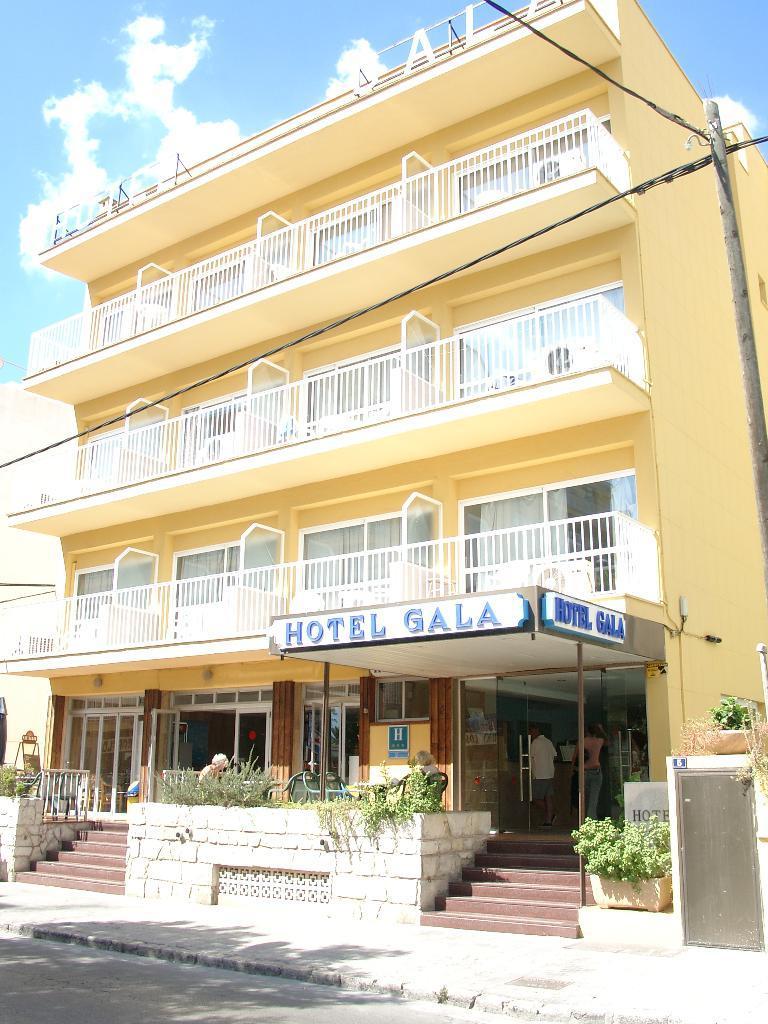Can you describe this image briefly? This picture is clicked outside. In the center we can see a yellow building and we can see the deck rails, windows, doors and the stairs of the building and we can see the text on the building and we can see the group of persons, potted plants, pole and cables. In the background there is a sky with the clouds. 